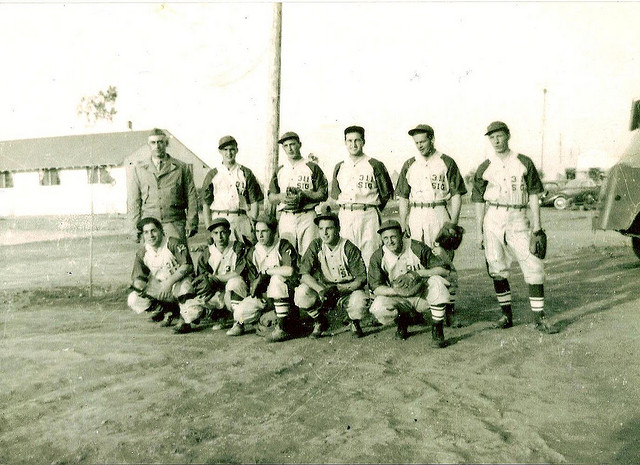<image>What number is on the yellow shirt? There is no yellow shirt in the image. However, the number can be '311', '12', '15', '5', '312 510', or '0'. What team are they playing for? I don't know what team they are playing for. It could be 'jays', 'mets', 'army', or 'yankees'. What number is on the yellow shirt? I am not sure what number is on the yellow shirt. It can be seen '311', '12', '15' or other numbers. What team are they playing for? I don't know which team they are playing for. It could be baseball, army, jays, mets or yankees. 